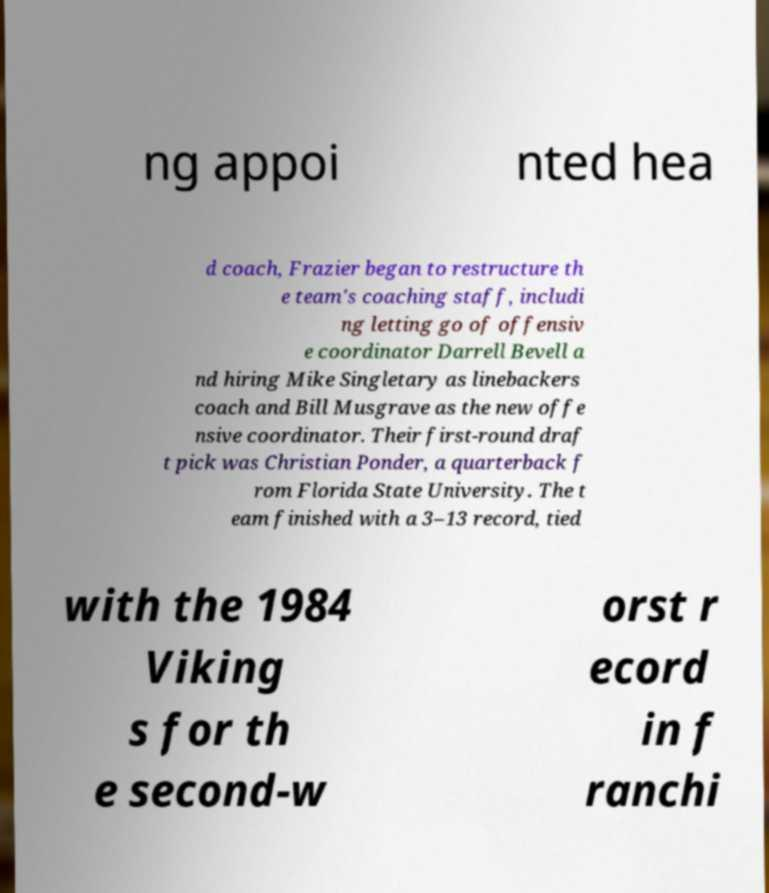What messages or text are displayed in this image? I need them in a readable, typed format. ng appoi nted hea d coach, Frazier began to restructure th e team's coaching staff, includi ng letting go of offensiv e coordinator Darrell Bevell a nd hiring Mike Singletary as linebackers coach and Bill Musgrave as the new offe nsive coordinator. Their first-round draf t pick was Christian Ponder, a quarterback f rom Florida State University. The t eam finished with a 3–13 record, tied with the 1984 Viking s for th e second-w orst r ecord in f ranchi 